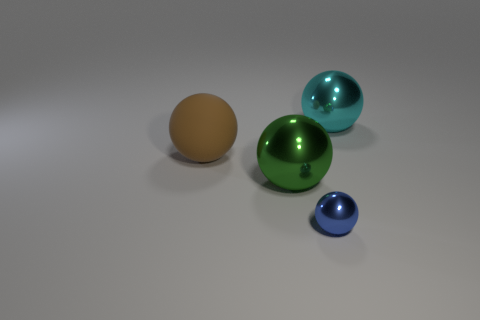Add 1 red shiny cubes. How many objects exist? 5 Add 1 green metal objects. How many green metal objects are left? 2 Add 1 big yellow rubber balls. How many big yellow rubber balls exist? 1 Subtract 0 green cylinders. How many objects are left? 4 Subtract all gray things. Subtract all green metal spheres. How many objects are left? 3 